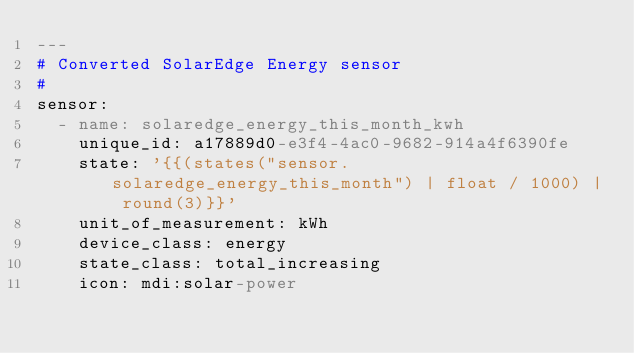Convert code to text. <code><loc_0><loc_0><loc_500><loc_500><_YAML_>---
# Converted SolarEdge Energy sensor
#
sensor:
  - name: solaredge_energy_this_month_kwh
    unique_id: a17889d0-e3f4-4ac0-9682-914a4f6390fe
    state: '{{(states("sensor.solaredge_energy_this_month") | float / 1000) | round(3)}}'
    unit_of_measurement: kWh
    device_class: energy
    state_class: total_increasing
    icon: mdi:solar-power
</code> 